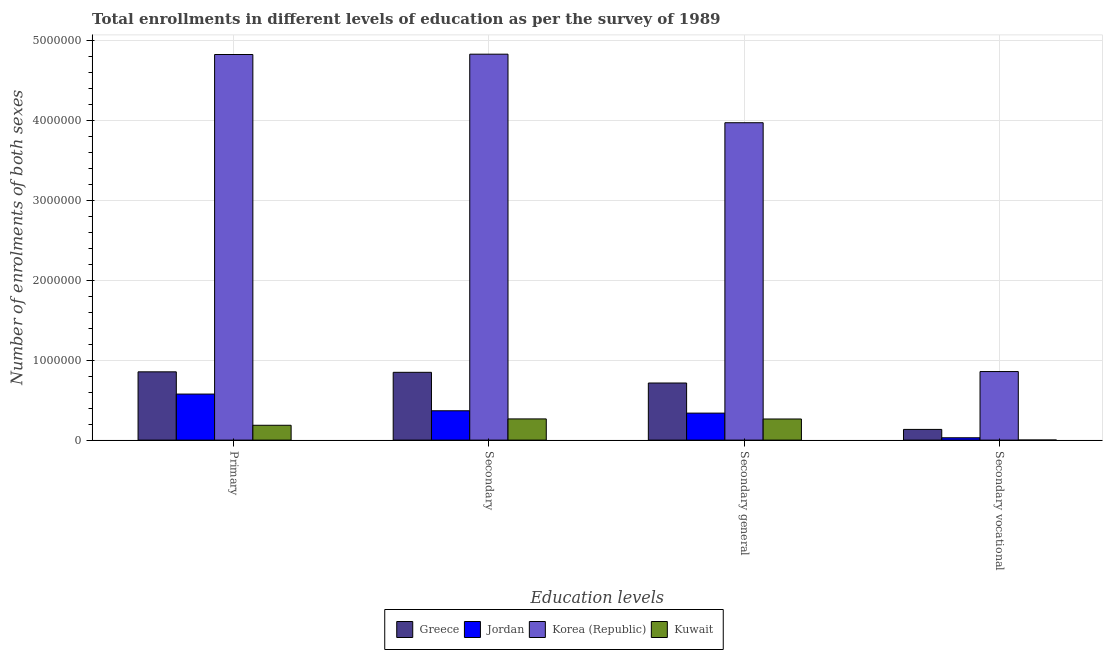How many groups of bars are there?
Make the answer very short. 4. Are the number of bars on each tick of the X-axis equal?
Make the answer very short. Yes. How many bars are there on the 2nd tick from the right?
Offer a very short reply. 4. What is the label of the 4th group of bars from the left?
Ensure brevity in your answer.  Secondary vocational. What is the number of enrolments in secondary education in Jordan?
Provide a short and direct response. 3.67e+05. Across all countries, what is the maximum number of enrolments in secondary vocational education?
Offer a very short reply. 8.57e+05. Across all countries, what is the minimum number of enrolments in secondary education?
Give a very brief answer. 2.65e+05. In which country was the number of enrolments in secondary general education minimum?
Ensure brevity in your answer.  Kuwait. What is the total number of enrolments in primary education in the graph?
Provide a succinct answer. 6.43e+06. What is the difference between the number of enrolments in secondary education in Korea (Republic) and that in Greece?
Keep it short and to the point. 3.98e+06. What is the difference between the number of enrolments in secondary vocational education in Korea (Republic) and the number of enrolments in secondary general education in Jordan?
Ensure brevity in your answer.  5.19e+05. What is the average number of enrolments in secondary general education per country?
Keep it short and to the point. 1.32e+06. What is the difference between the number of enrolments in secondary general education and number of enrolments in secondary vocational education in Greece?
Make the answer very short. 5.80e+05. In how many countries, is the number of enrolments in secondary vocational education greater than 2400000 ?
Ensure brevity in your answer.  0. What is the ratio of the number of enrolments in primary education in Greece to that in Korea (Republic)?
Offer a terse response. 0.18. What is the difference between the highest and the second highest number of enrolments in secondary education?
Provide a succinct answer. 3.98e+06. What is the difference between the highest and the lowest number of enrolments in secondary vocational education?
Provide a succinct answer. 8.56e+05. Is the sum of the number of enrolments in secondary general education in Greece and Kuwait greater than the maximum number of enrolments in primary education across all countries?
Provide a succinct answer. No. What does the 2nd bar from the left in Secondary general represents?
Your answer should be compact. Jordan. What does the 1st bar from the right in Secondary represents?
Ensure brevity in your answer.  Kuwait. How many countries are there in the graph?
Your answer should be very brief. 4. Does the graph contain grids?
Ensure brevity in your answer.  Yes. How many legend labels are there?
Offer a very short reply. 4. How are the legend labels stacked?
Offer a very short reply. Horizontal. What is the title of the graph?
Give a very brief answer. Total enrollments in different levels of education as per the survey of 1989. Does "Least developed countries" appear as one of the legend labels in the graph?
Provide a succinct answer. No. What is the label or title of the X-axis?
Your answer should be very brief. Education levels. What is the label or title of the Y-axis?
Your answer should be compact. Number of enrolments of both sexes. What is the Number of enrolments of both sexes in Greece in Primary?
Offer a terse response. 8.54e+05. What is the Number of enrolments of both sexes of Jordan in Primary?
Make the answer very short. 5.75e+05. What is the Number of enrolments of both sexes of Korea (Republic) in Primary?
Your answer should be compact. 4.82e+06. What is the Number of enrolments of both sexes in Kuwait in Primary?
Your answer should be compact. 1.85e+05. What is the Number of enrolments of both sexes in Greece in Secondary?
Offer a terse response. 8.47e+05. What is the Number of enrolments of both sexes of Jordan in Secondary?
Your response must be concise. 3.67e+05. What is the Number of enrolments of both sexes of Korea (Republic) in Secondary?
Your response must be concise. 4.82e+06. What is the Number of enrolments of both sexes in Kuwait in Secondary?
Your answer should be compact. 2.65e+05. What is the Number of enrolments of both sexes of Greece in Secondary general?
Ensure brevity in your answer.  7.14e+05. What is the Number of enrolments of both sexes in Jordan in Secondary general?
Provide a short and direct response. 3.38e+05. What is the Number of enrolments of both sexes of Korea (Republic) in Secondary general?
Offer a terse response. 3.97e+06. What is the Number of enrolments of both sexes in Kuwait in Secondary general?
Your answer should be compact. 2.64e+05. What is the Number of enrolments of both sexes of Greece in Secondary vocational?
Provide a succinct answer. 1.34e+05. What is the Number of enrolments of both sexes in Jordan in Secondary vocational?
Give a very brief answer. 2.92e+04. What is the Number of enrolments of both sexes in Korea (Republic) in Secondary vocational?
Ensure brevity in your answer.  8.57e+05. What is the Number of enrolments of both sexes in Kuwait in Secondary vocational?
Your answer should be compact. 863. Across all Education levels, what is the maximum Number of enrolments of both sexes of Greece?
Provide a succinct answer. 8.54e+05. Across all Education levels, what is the maximum Number of enrolments of both sexes of Jordan?
Ensure brevity in your answer.  5.75e+05. Across all Education levels, what is the maximum Number of enrolments of both sexes in Korea (Republic)?
Ensure brevity in your answer.  4.82e+06. Across all Education levels, what is the maximum Number of enrolments of both sexes of Kuwait?
Ensure brevity in your answer.  2.65e+05. Across all Education levels, what is the minimum Number of enrolments of both sexes in Greece?
Provide a succinct answer. 1.34e+05. Across all Education levels, what is the minimum Number of enrolments of both sexes of Jordan?
Your answer should be very brief. 2.92e+04. Across all Education levels, what is the minimum Number of enrolments of both sexes in Korea (Republic)?
Offer a terse response. 8.57e+05. Across all Education levels, what is the minimum Number of enrolments of both sexes in Kuwait?
Ensure brevity in your answer.  863. What is the total Number of enrolments of both sexes in Greece in the graph?
Keep it short and to the point. 2.55e+06. What is the total Number of enrolments of both sexes of Jordan in the graph?
Provide a succinct answer. 1.31e+06. What is the total Number of enrolments of both sexes in Korea (Republic) in the graph?
Keep it short and to the point. 1.45e+07. What is the total Number of enrolments of both sexes of Kuwait in the graph?
Your answer should be compact. 7.15e+05. What is the difference between the Number of enrolments of both sexes in Greece in Primary and that in Secondary?
Your answer should be very brief. 6032. What is the difference between the Number of enrolments of both sexes of Jordan in Primary and that in Secondary?
Make the answer very short. 2.09e+05. What is the difference between the Number of enrolments of both sexes of Korea (Republic) in Primary and that in Secondary?
Offer a very short reply. -4240. What is the difference between the Number of enrolments of both sexes in Kuwait in Primary and that in Secondary?
Keep it short and to the point. -7.95e+04. What is the difference between the Number of enrolments of both sexes in Greece in Primary and that in Secondary general?
Ensure brevity in your answer.  1.40e+05. What is the difference between the Number of enrolments of both sexes of Jordan in Primary and that in Secondary general?
Your answer should be compact. 2.38e+05. What is the difference between the Number of enrolments of both sexes of Korea (Republic) in Primary and that in Secondary general?
Ensure brevity in your answer.  8.53e+05. What is the difference between the Number of enrolments of both sexes in Kuwait in Primary and that in Secondary general?
Make the answer very short. -7.87e+04. What is the difference between the Number of enrolments of both sexes in Greece in Primary and that in Secondary vocational?
Provide a succinct answer. 7.20e+05. What is the difference between the Number of enrolments of both sexes of Jordan in Primary and that in Secondary vocational?
Your answer should be very brief. 5.46e+05. What is the difference between the Number of enrolments of both sexes of Korea (Republic) in Primary and that in Secondary vocational?
Ensure brevity in your answer.  3.96e+06. What is the difference between the Number of enrolments of both sexes of Kuwait in Primary and that in Secondary vocational?
Your response must be concise. 1.85e+05. What is the difference between the Number of enrolments of both sexes in Greece in Secondary and that in Secondary general?
Provide a short and direct response. 1.34e+05. What is the difference between the Number of enrolments of both sexes in Jordan in Secondary and that in Secondary general?
Ensure brevity in your answer.  2.92e+04. What is the difference between the Number of enrolments of both sexes in Korea (Republic) in Secondary and that in Secondary general?
Provide a succinct answer. 8.57e+05. What is the difference between the Number of enrolments of both sexes in Kuwait in Secondary and that in Secondary general?
Ensure brevity in your answer.  863. What is the difference between the Number of enrolments of both sexes in Greece in Secondary and that in Secondary vocational?
Your answer should be very brief. 7.14e+05. What is the difference between the Number of enrolments of both sexes in Jordan in Secondary and that in Secondary vocational?
Offer a very short reply. 3.38e+05. What is the difference between the Number of enrolments of both sexes in Korea (Republic) in Secondary and that in Secondary vocational?
Provide a succinct answer. 3.97e+06. What is the difference between the Number of enrolments of both sexes of Kuwait in Secondary and that in Secondary vocational?
Keep it short and to the point. 2.64e+05. What is the difference between the Number of enrolments of both sexes in Greece in Secondary general and that in Secondary vocational?
Provide a succinct answer. 5.80e+05. What is the difference between the Number of enrolments of both sexes of Jordan in Secondary general and that in Secondary vocational?
Your response must be concise. 3.08e+05. What is the difference between the Number of enrolments of both sexes in Korea (Republic) in Secondary general and that in Secondary vocational?
Provide a short and direct response. 3.11e+06. What is the difference between the Number of enrolments of both sexes of Kuwait in Secondary general and that in Secondary vocational?
Make the answer very short. 2.63e+05. What is the difference between the Number of enrolments of both sexes in Greece in Primary and the Number of enrolments of both sexes in Jordan in Secondary?
Your response must be concise. 4.87e+05. What is the difference between the Number of enrolments of both sexes of Greece in Primary and the Number of enrolments of both sexes of Korea (Republic) in Secondary?
Make the answer very short. -3.97e+06. What is the difference between the Number of enrolments of both sexes in Greece in Primary and the Number of enrolments of both sexes in Kuwait in Secondary?
Give a very brief answer. 5.89e+05. What is the difference between the Number of enrolments of both sexes of Jordan in Primary and the Number of enrolments of both sexes of Korea (Republic) in Secondary?
Your response must be concise. -4.25e+06. What is the difference between the Number of enrolments of both sexes of Jordan in Primary and the Number of enrolments of both sexes of Kuwait in Secondary?
Provide a short and direct response. 3.10e+05. What is the difference between the Number of enrolments of both sexes in Korea (Republic) in Primary and the Number of enrolments of both sexes in Kuwait in Secondary?
Give a very brief answer. 4.55e+06. What is the difference between the Number of enrolments of both sexes in Greece in Primary and the Number of enrolments of both sexes in Jordan in Secondary general?
Keep it short and to the point. 5.16e+05. What is the difference between the Number of enrolments of both sexes of Greece in Primary and the Number of enrolments of both sexes of Korea (Republic) in Secondary general?
Offer a terse response. -3.11e+06. What is the difference between the Number of enrolments of both sexes of Greece in Primary and the Number of enrolments of both sexes of Kuwait in Secondary general?
Make the answer very short. 5.89e+05. What is the difference between the Number of enrolments of both sexes of Jordan in Primary and the Number of enrolments of both sexes of Korea (Republic) in Secondary general?
Offer a terse response. -3.39e+06. What is the difference between the Number of enrolments of both sexes in Jordan in Primary and the Number of enrolments of both sexes in Kuwait in Secondary general?
Your response must be concise. 3.11e+05. What is the difference between the Number of enrolments of both sexes in Korea (Republic) in Primary and the Number of enrolments of both sexes in Kuwait in Secondary general?
Provide a succinct answer. 4.56e+06. What is the difference between the Number of enrolments of both sexes in Greece in Primary and the Number of enrolments of both sexes in Jordan in Secondary vocational?
Give a very brief answer. 8.24e+05. What is the difference between the Number of enrolments of both sexes in Greece in Primary and the Number of enrolments of both sexes in Korea (Republic) in Secondary vocational?
Your answer should be compact. -3363. What is the difference between the Number of enrolments of both sexes of Greece in Primary and the Number of enrolments of both sexes of Kuwait in Secondary vocational?
Your answer should be very brief. 8.53e+05. What is the difference between the Number of enrolments of both sexes in Jordan in Primary and the Number of enrolments of both sexes in Korea (Republic) in Secondary vocational?
Offer a terse response. -2.81e+05. What is the difference between the Number of enrolments of both sexes of Jordan in Primary and the Number of enrolments of both sexes of Kuwait in Secondary vocational?
Provide a succinct answer. 5.75e+05. What is the difference between the Number of enrolments of both sexes in Korea (Republic) in Primary and the Number of enrolments of both sexes in Kuwait in Secondary vocational?
Your response must be concise. 4.82e+06. What is the difference between the Number of enrolments of both sexes of Greece in Secondary and the Number of enrolments of both sexes of Jordan in Secondary general?
Your answer should be compact. 5.10e+05. What is the difference between the Number of enrolments of both sexes of Greece in Secondary and the Number of enrolments of both sexes of Korea (Republic) in Secondary general?
Provide a short and direct response. -3.12e+06. What is the difference between the Number of enrolments of both sexes of Greece in Secondary and the Number of enrolments of both sexes of Kuwait in Secondary general?
Ensure brevity in your answer.  5.83e+05. What is the difference between the Number of enrolments of both sexes in Jordan in Secondary and the Number of enrolments of both sexes in Korea (Republic) in Secondary general?
Offer a very short reply. -3.60e+06. What is the difference between the Number of enrolments of both sexes in Jordan in Secondary and the Number of enrolments of both sexes in Kuwait in Secondary general?
Provide a succinct answer. 1.03e+05. What is the difference between the Number of enrolments of both sexes in Korea (Republic) in Secondary and the Number of enrolments of both sexes in Kuwait in Secondary general?
Keep it short and to the point. 4.56e+06. What is the difference between the Number of enrolments of both sexes in Greece in Secondary and the Number of enrolments of both sexes in Jordan in Secondary vocational?
Keep it short and to the point. 8.18e+05. What is the difference between the Number of enrolments of both sexes in Greece in Secondary and the Number of enrolments of both sexes in Korea (Republic) in Secondary vocational?
Offer a very short reply. -9395. What is the difference between the Number of enrolments of both sexes of Greece in Secondary and the Number of enrolments of both sexes of Kuwait in Secondary vocational?
Give a very brief answer. 8.47e+05. What is the difference between the Number of enrolments of both sexes of Jordan in Secondary and the Number of enrolments of both sexes of Korea (Republic) in Secondary vocational?
Make the answer very short. -4.90e+05. What is the difference between the Number of enrolments of both sexes in Jordan in Secondary and the Number of enrolments of both sexes in Kuwait in Secondary vocational?
Offer a terse response. 3.66e+05. What is the difference between the Number of enrolments of both sexes in Korea (Republic) in Secondary and the Number of enrolments of both sexes in Kuwait in Secondary vocational?
Your response must be concise. 4.82e+06. What is the difference between the Number of enrolments of both sexes in Greece in Secondary general and the Number of enrolments of both sexes in Jordan in Secondary vocational?
Your response must be concise. 6.85e+05. What is the difference between the Number of enrolments of both sexes of Greece in Secondary general and the Number of enrolments of both sexes of Korea (Republic) in Secondary vocational?
Your response must be concise. -1.43e+05. What is the difference between the Number of enrolments of both sexes of Greece in Secondary general and the Number of enrolments of both sexes of Kuwait in Secondary vocational?
Offer a terse response. 7.13e+05. What is the difference between the Number of enrolments of both sexes in Jordan in Secondary general and the Number of enrolments of both sexes in Korea (Republic) in Secondary vocational?
Keep it short and to the point. -5.19e+05. What is the difference between the Number of enrolments of both sexes of Jordan in Secondary general and the Number of enrolments of both sexes of Kuwait in Secondary vocational?
Ensure brevity in your answer.  3.37e+05. What is the difference between the Number of enrolments of both sexes in Korea (Republic) in Secondary general and the Number of enrolments of both sexes in Kuwait in Secondary vocational?
Offer a terse response. 3.97e+06. What is the average Number of enrolments of both sexes in Greece per Education levels?
Your response must be concise. 6.37e+05. What is the average Number of enrolments of both sexes of Jordan per Education levels?
Provide a succinct answer. 3.27e+05. What is the average Number of enrolments of both sexes in Korea (Republic) per Education levels?
Your answer should be compact. 3.62e+06. What is the average Number of enrolments of both sexes in Kuwait per Education levels?
Provide a short and direct response. 1.79e+05. What is the difference between the Number of enrolments of both sexes in Greece and Number of enrolments of both sexes in Jordan in Primary?
Give a very brief answer. 2.78e+05. What is the difference between the Number of enrolments of both sexes of Greece and Number of enrolments of both sexes of Korea (Republic) in Primary?
Keep it short and to the point. -3.97e+06. What is the difference between the Number of enrolments of both sexes in Greece and Number of enrolments of both sexes in Kuwait in Primary?
Give a very brief answer. 6.68e+05. What is the difference between the Number of enrolments of both sexes of Jordan and Number of enrolments of both sexes of Korea (Republic) in Primary?
Your response must be concise. -4.24e+06. What is the difference between the Number of enrolments of both sexes of Jordan and Number of enrolments of both sexes of Kuwait in Primary?
Your answer should be very brief. 3.90e+05. What is the difference between the Number of enrolments of both sexes of Korea (Republic) and Number of enrolments of both sexes of Kuwait in Primary?
Ensure brevity in your answer.  4.63e+06. What is the difference between the Number of enrolments of both sexes of Greece and Number of enrolments of both sexes of Jordan in Secondary?
Offer a very short reply. 4.81e+05. What is the difference between the Number of enrolments of both sexes of Greece and Number of enrolments of both sexes of Korea (Republic) in Secondary?
Make the answer very short. -3.98e+06. What is the difference between the Number of enrolments of both sexes of Greece and Number of enrolments of both sexes of Kuwait in Secondary?
Offer a very short reply. 5.82e+05. What is the difference between the Number of enrolments of both sexes of Jordan and Number of enrolments of both sexes of Korea (Republic) in Secondary?
Provide a succinct answer. -4.46e+06. What is the difference between the Number of enrolments of both sexes in Jordan and Number of enrolments of both sexes in Kuwait in Secondary?
Offer a very short reply. 1.02e+05. What is the difference between the Number of enrolments of both sexes in Korea (Republic) and Number of enrolments of both sexes in Kuwait in Secondary?
Your answer should be compact. 4.56e+06. What is the difference between the Number of enrolments of both sexes in Greece and Number of enrolments of both sexes in Jordan in Secondary general?
Ensure brevity in your answer.  3.76e+05. What is the difference between the Number of enrolments of both sexes of Greece and Number of enrolments of both sexes of Korea (Republic) in Secondary general?
Make the answer very short. -3.25e+06. What is the difference between the Number of enrolments of both sexes of Greece and Number of enrolments of both sexes of Kuwait in Secondary general?
Offer a very short reply. 4.50e+05. What is the difference between the Number of enrolments of both sexes of Jordan and Number of enrolments of both sexes of Korea (Republic) in Secondary general?
Keep it short and to the point. -3.63e+06. What is the difference between the Number of enrolments of both sexes in Jordan and Number of enrolments of both sexes in Kuwait in Secondary general?
Keep it short and to the point. 7.34e+04. What is the difference between the Number of enrolments of both sexes in Korea (Republic) and Number of enrolments of both sexes in Kuwait in Secondary general?
Give a very brief answer. 3.70e+06. What is the difference between the Number of enrolments of both sexes in Greece and Number of enrolments of both sexes in Jordan in Secondary vocational?
Your answer should be compact. 1.05e+05. What is the difference between the Number of enrolments of both sexes of Greece and Number of enrolments of both sexes of Korea (Republic) in Secondary vocational?
Your answer should be very brief. -7.23e+05. What is the difference between the Number of enrolments of both sexes in Greece and Number of enrolments of both sexes in Kuwait in Secondary vocational?
Your answer should be very brief. 1.33e+05. What is the difference between the Number of enrolments of both sexes of Jordan and Number of enrolments of both sexes of Korea (Republic) in Secondary vocational?
Keep it short and to the point. -8.28e+05. What is the difference between the Number of enrolments of both sexes of Jordan and Number of enrolments of both sexes of Kuwait in Secondary vocational?
Ensure brevity in your answer.  2.84e+04. What is the difference between the Number of enrolments of both sexes of Korea (Republic) and Number of enrolments of both sexes of Kuwait in Secondary vocational?
Ensure brevity in your answer.  8.56e+05. What is the ratio of the Number of enrolments of both sexes in Greece in Primary to that in Secondary?
Your answer should be compact. 1.01. What is the ratio of the Number of enrolments of both sexes of Jordan in Primary to that in Secondary?
Provide a short and direct response. 1.57. What is the ratio of the Number of enrolments of both sexes of Korea (Republic) in Primary to that in Secondary?
Your response must be concise. 1. What is the ratio of the Number of enrolments of both sexes of Kuwait in Primary to that in Secondary?
Keep it short and to the point. 0.7. What is the ratio of the Number of enrolments of both sexes in Greece in Primary to that in Secondary general?
Provide a succinct answer. 1.2. What is the ratio of the Number of enrolments of both sexes in Jordan in Primary to that in Secondary general?
Your answer should be compact. 1.7. What is the ratio of the Number of enrolments of both sexes in Korea (Republic) in Primary to that in Secondary general?
Offer a terse response. 1.21. What is the ratio of the Number of enrolments of both sexes of Kuwait in Primary to that in Secondary general?
Ensure brevity in your answer.  0.7. What is the ratio of the Number of enrolments of both sexes in Greece in Primary to that in Secondary vocational?
Offer a terse response. 6.38. What is the ratio of the Number of enrolments of both sexes of Jordan in Primary to that in Secondary vocational?
Provide a succinct answer. 19.68. What is the ratio of the Number of enrolments of both sexes in Korea (Republic) in Primary to that in Secondary vocational?
Make the answer very short. 5.62. What is the ratio of the Number of enrolments of both sexes in Kuwait in Primary to that in Secondary vocational?
Ensure brevity in your answer.  214.91. What is the ratio of the Number of enrolments of both sexes in Greece in Secondary to that in Secondary general?
Provide a succinct answer. 1.19. What is the ratio of the Number of enrolments of both sexes of Jordan in Secondary to that in Secondary general?
Provide a short and direct response. 1.09. What is the ratio of the Number of enrolments of both sexes of Korea (Republic) in Secondary to that in Secondary general?
Your response must be concise. 1.22. What is the ratio of the Number of enrolments of both sexes of Greece in Secondary to that in Secondary vocational?
Keep it short and to the point. 6.34. What is the ratio of the Number of enrolments of both sexes of Jordan in Secondary to that in Secondary vocational?
Provide a short and direct response. 12.55. What is the ratio of the Number of enrolments of both sexes in Korea (Republic) in Secondary to that in Secondary vocational?
Offer a very short reply. 5.63. What is the ratio of the Number of enrolments of both sexes of Kuwait in Secondary to that in Secondary vocational?
Keep it short and to the point. 307.07. What is the ratio of the Number of enrolments of both sexes in Greece in Secondary general to that in Secondary vocational?
Provide a short and direct response. 5.34. What is the ratio of the Number of enrolments of both sexes of Jordan in Secondary general to that in Secondary vocational?
Provide a succinct answer. 11.55. What is the ratio of the Number of enrolments of both sexes of Korea (Republic) in Secondary general to that in Secondary vocational?
Ensure brevity in your answer.  4.63. What is the ratio of the Number of enrolments of both sexes of Kuwait in Secondary general to that in Secondary vocational?
Ensure brevity in your answer.  306.07. What is the difference between the highest and the second highest Number of enrolments of both sexes in Greece?
Give a very brief answer. 6032. What is the difference between the highest and the second highest Number of enrolments of both sexes in Jordan?
Provide a short and direct response. 2.09e+05. What is the difference between the highest and the second highest Number of enrolments of both sexes in Korea (Republic)?
Ensure brevity in your answer.  4240. What is the difference between the highest and the second highest Number of enrolments of both sexes of Kuwait?
Offer a terse response. 863. What is the difference between the highest and the lowest Number of enrolments of both sexes in Greece?
Provide a succinct answer. 7.20e+05. What is the difference between the highest and the lowest Number of enrolments of both sexes in Jordan?
Your answer should be compact. 5.46e+05. What is the difference between the highest and the lowest Number of enrolments of both sexes in Korea (Republic)?
Keep it short and to the point. 3.97e+06. What is the difference between the highest and the lowest Number of enrolments of both sexes of Kuwait?
Provide a short and direct response. 2.64e+05. 